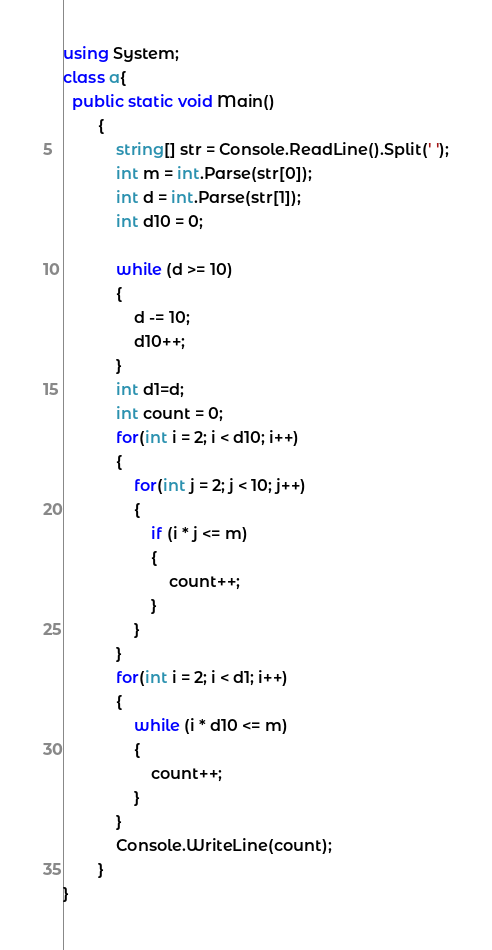Convert code to text. <code><loc_0><loc_0><loc_500><loc_500><_C#_>using System;
class a{
  public static void Main()
        {
            string[] str = Console.ReadLine().Split(' ');
            int m = int.Parse(str[0]);
            int d = int.Parse(str[1]);
            int d10 = 0;

            while (d >= 10)
            {
                d -= 10;
                d10++;
            }
            int d1=d;
            int count = 0;
            for(int i = 2; i < d10; i++)
            {
                for(int j = 2; j < 10; j++)
                {
                    if (i * j <= m)
                    {
                        count++;
                    }
                }
            }
            for(int i = 2; i < d1; i++)
            {
                while (i * d10 <= m)
                {
                    count++;
                }
            }
            Console.WriteLine(count);
        }
}</code> 